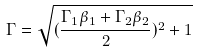<formula> <loc_0><loc_0><loc_500><loc_500>\Gamma = \sqrt { ( \frac { \Gamma _ { 1 } \beta _ { 1 } + \Gamma _ { 2 } \beta _ { 2 } } { 2 } ) ^ { 2 } + 1 }</formula> 